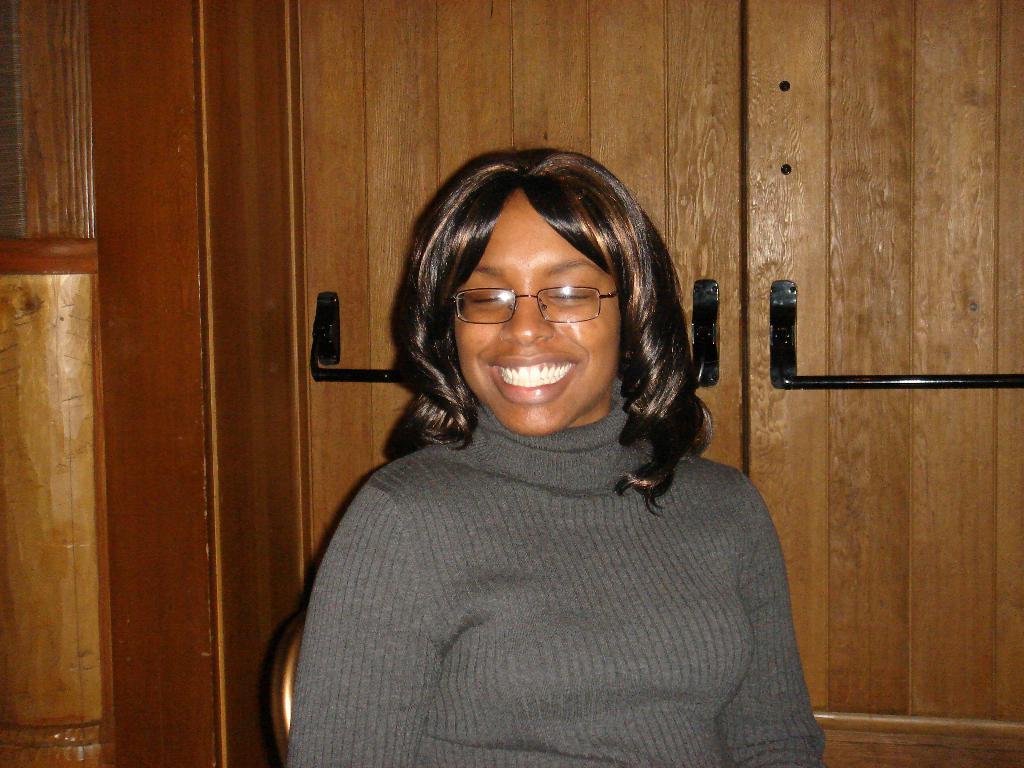Can you describe this image briefly? In this image I can see a woman wearing a t-shirt, sitting on a chair, smiling and giving pose for the picture. At the back of her I can see a cupboard. 